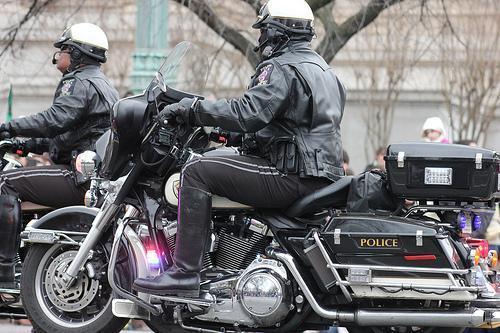How many bikes are shown?
Give a very brief answer. 2. 